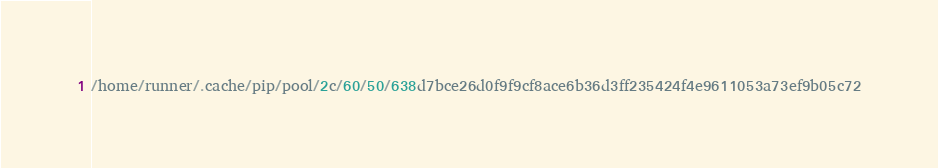Convert code to text. <code><loc_0><loc_0><loc_500><loc_500><_Python_>/home/runner/.cache/pip/pool/2c/60/50/638d7bce26d0f9f9cf8ace6b36d3ff235424f4e9611053a73ef9b05c72</code> 